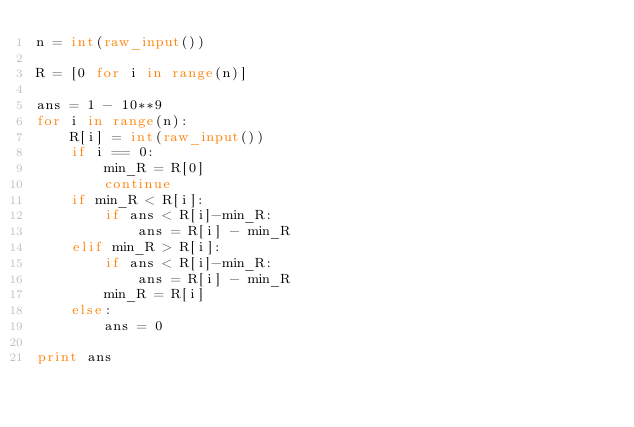<code> <loc_0><loc_0><loc_500><loc_500><_Python_>n = int(raw_input())

R = [0 for i in range(n)]

ans = 1 - 10**9
for i in range(n):
    R[i] = int(raw_input())
    if i == 0:
        min_R = R[0]
        continue
    if min_R < R[i]:
        if ans < R[i]-min_R:
            ans = R[i] - min_R
    elif min_R > R[i]:
        if ans < R[i]-min_R:
            ans = R[i] - min_R
        min_R = R[i]
    else:
        ans = 0
        
print ans
    
    
    </code> 